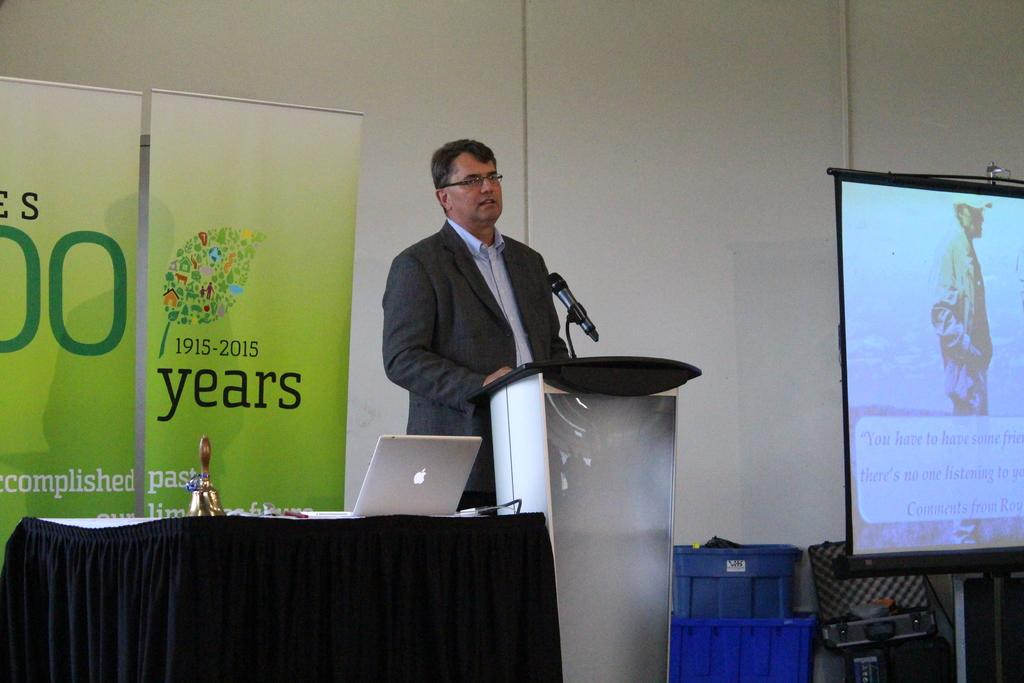<image>
Create a compact narrative representing the image presented. A banner with the years 1915-2015 displaying next to a speaker. 